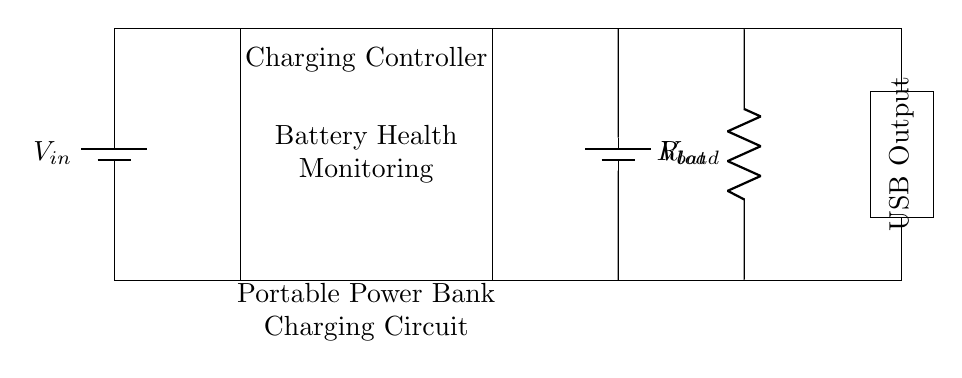What is the input voltage in the circuit? The input voltage is represented by the battery labeled 'Vin' in the circuit diagram. It is located at the top left corner where the battery symbol is drawn.
Answer: Vin What is the purpose of the rectangle labeled "Charging Controller"? The rectangle labeled "Charging Controller" indicates the component responsible for managing the battery charging process and also performing battery health monitoring functions, as indicated by the text inside it.
Answer: Charging and health monitoring How many batteries are depicted in the circuit? There are two batteries shown in the circuit diagram: one for input voltage 'Vin' and one for the output voltage 'Vbat'. They are both represented by battery symbols on the left and right sides of the diagram.
Answer: Two What is the current flow direction in the circuit? The current flows from the input battery, through the charging controller, into the output battery, and finally to the load. The arrows are implicit in the connection lines but follow the conventional flow from higher to lower potential.
Answer: From left to right What is the function of the "USB Output" in the circuit? The "USB Output" provides a standard interface for connecting devices to draw power from the portable power bank. It is a designated output section in the circuit indicating where external devices can charge.
Answer: Power output What does the resistor labeled "Rload" represent? The resistor labeled 'Rload' represents the load in the circuit. This is the component that uses the power supplied by the battery, simulating a device that is consuming energy from the power bank during operation.
Answer: Load What is the significance of battery health monitoring in this circuit? Battery health monitoring is important as it ensures that the battery operates safely and efficiently, preventing overcharging or excessive discharging. This component is crucial for prolonging battery life and performance, as indicated in the text inside the charging controller.
Answer: Prolongs battery life 